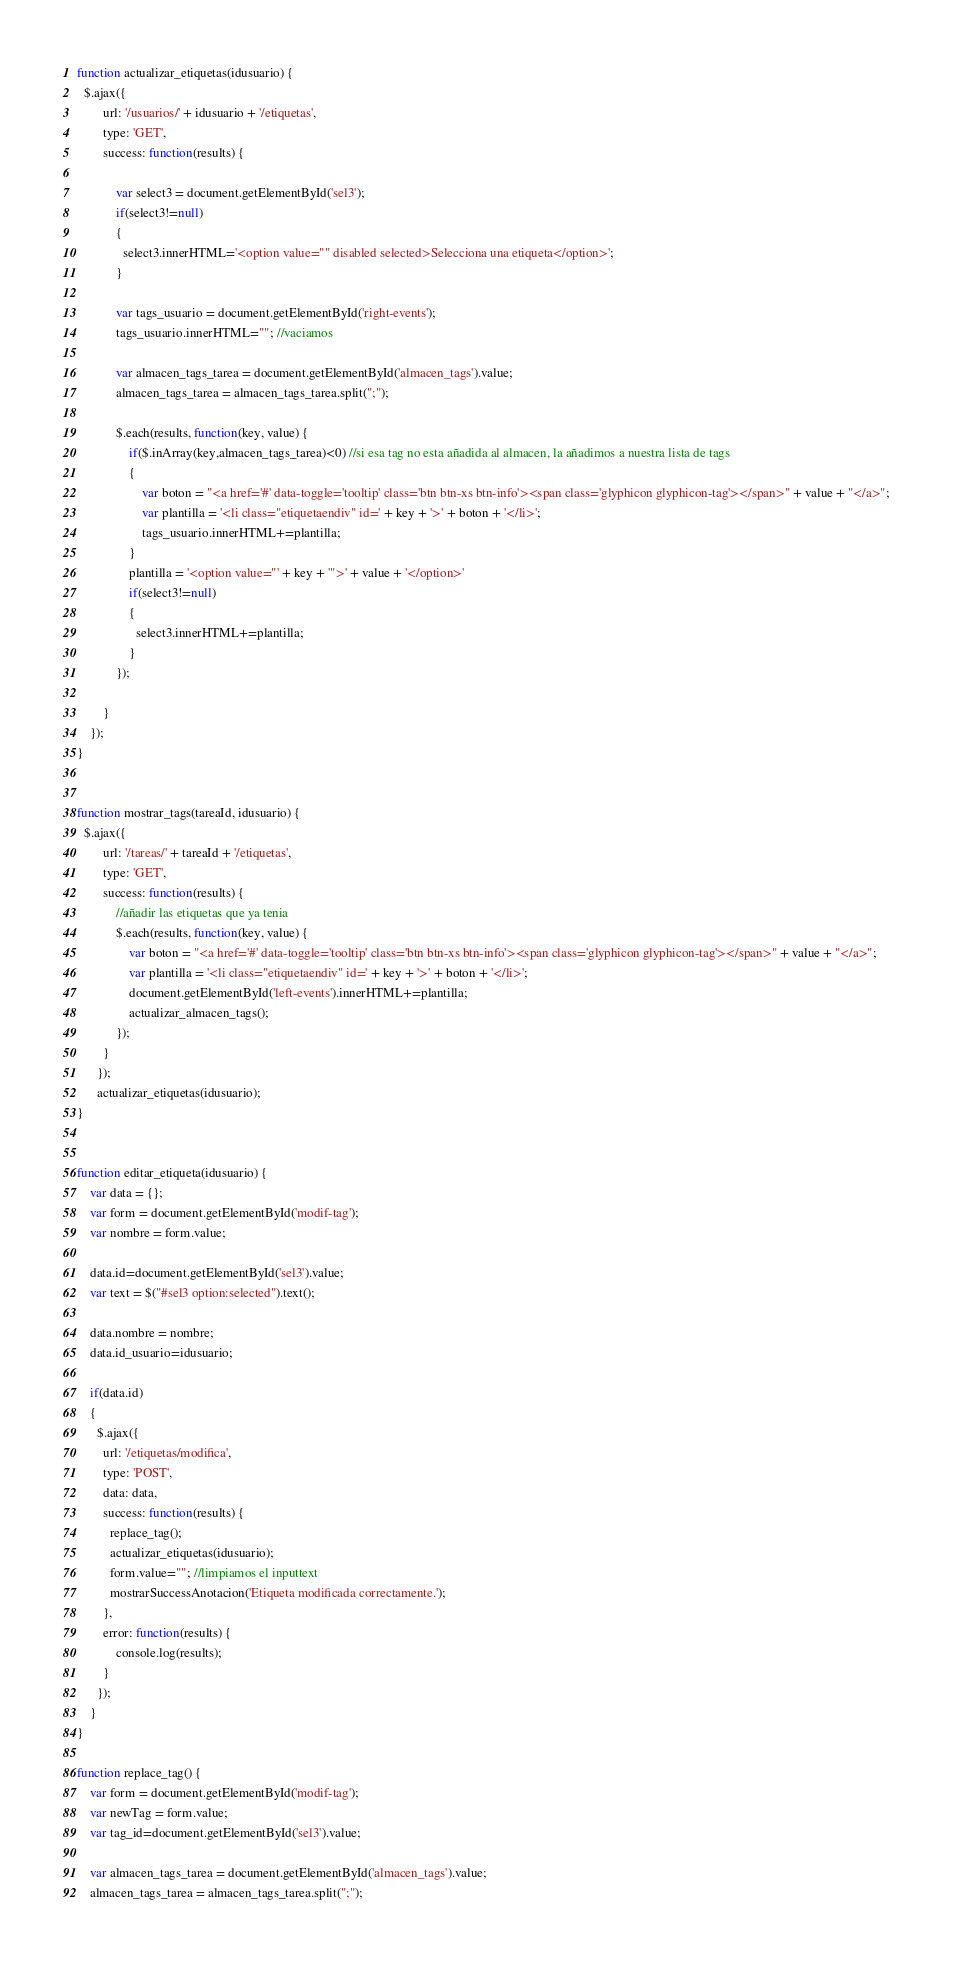Convert code to text. <code><loc_0><loc_0><loc_500><loc_500><_JavaScript_>
function actualizar_etiquetas(idusuario) {
  $.ajax({
        url: '/usuarios/' + idusuario + '/etiquetas',
        type: 'GET',
        success: function(results) {

            var select3 = document.getElementById('sel3');
            if(select3!=null)
            {
              select3.innerHTML='<option value="" disabled selected>Selecciona una etiqueta</option>';
            }

            var tags_usuario = document.getElementById('right-events');
            tags_usuario.innerHTML=""; //vaciamos

            var almacen_tags_tarea = document.getElementById('almacen_tags').value;
            almacen_tags_tarea = almacen_tags_tarea.split(";");

            $.each(results, function(key, value) {
                if($.inArray(key,almacen_tags_tarea)<0) //si esa tag no esta añadida al almacen, la añadimos a nuestra lista de tags
                {
                    var boton = "<a href='#' data-toggle='tooltip' class='btn btn-xs btn-info'><span class='glyphicon glyphicon-tag'></span>" + value + "</a>";
                    var plantilla = '<li class="etiquetaendiv" id=' + key + '>' + boton + '</li>';
                    tags_usuario.innerHTML+=plantilla;
                }
                plantilla = '<option value="' + key + '">' + value + '</option>'
                if(select3!=null)
                {
                  select3.innerHTML+=plantilla;
                }
            });

        }
    });
}


function mostrar_tags(tareaId, idusuario) {
  $.ajax({
        url: '/tareas/' + tareaId + '/etiquetas',
        type: 'GET',
        success: function(results) {
            //añadir las etiquetas que ya tenia
            $.each(results, function(key, value) {
                var boton = "<a href='#' data-toggle='tooltip' class='btn btn-xs btn-info'><span class='glyphicon glyphicon-tag'></span>" + value + "</a>";
                var plantilla = '<li class="etiquetaendiv" id=' + key + '>' + boton + '</li>';
                document.getElementById('left-events').innerHTML+=plantilla;
                actualizar_almacen_tags();
            });
        }
      });
      actualizar_etiquetas(idusuario);
}


function editar_etiqueta(idusuario) {
    var data = {};
    var form = document.getElementById('modif-tag');
    var nombre = form.value;

    data.id=document.getElementById('sel3').value;
    var text = $("#sel3 option:selected").text();

    data.nombre = nombre;
    data.id_usuario=idusuario;

    if(data.id)
    {
      $.ajax({
        url: '/etiquetas/modifica',
        type: 'POST',
        data: data,
        success: function(results) {
          replace_tag();
          actualizar_etiquetas(idusuario);
          form.value=""; //limpiamos el inputtext
          mostrarSuccessAnotacion('Etiqueta modificada correctamente.');
        },
        error: function(results) {
            console.log(results);
        }
      });
    }
}

function replace_tag() {
    var form = document.getElementById('modif-tag');
    var newTag = form.value;
    var tag_id=document.getElementById('sel3').value;

    var almacen_tags_tarea = document.getElementById('almacen_tags').value;
    almacen_tags_tarea = almacen_tags_tarea.split(";");
</code> 